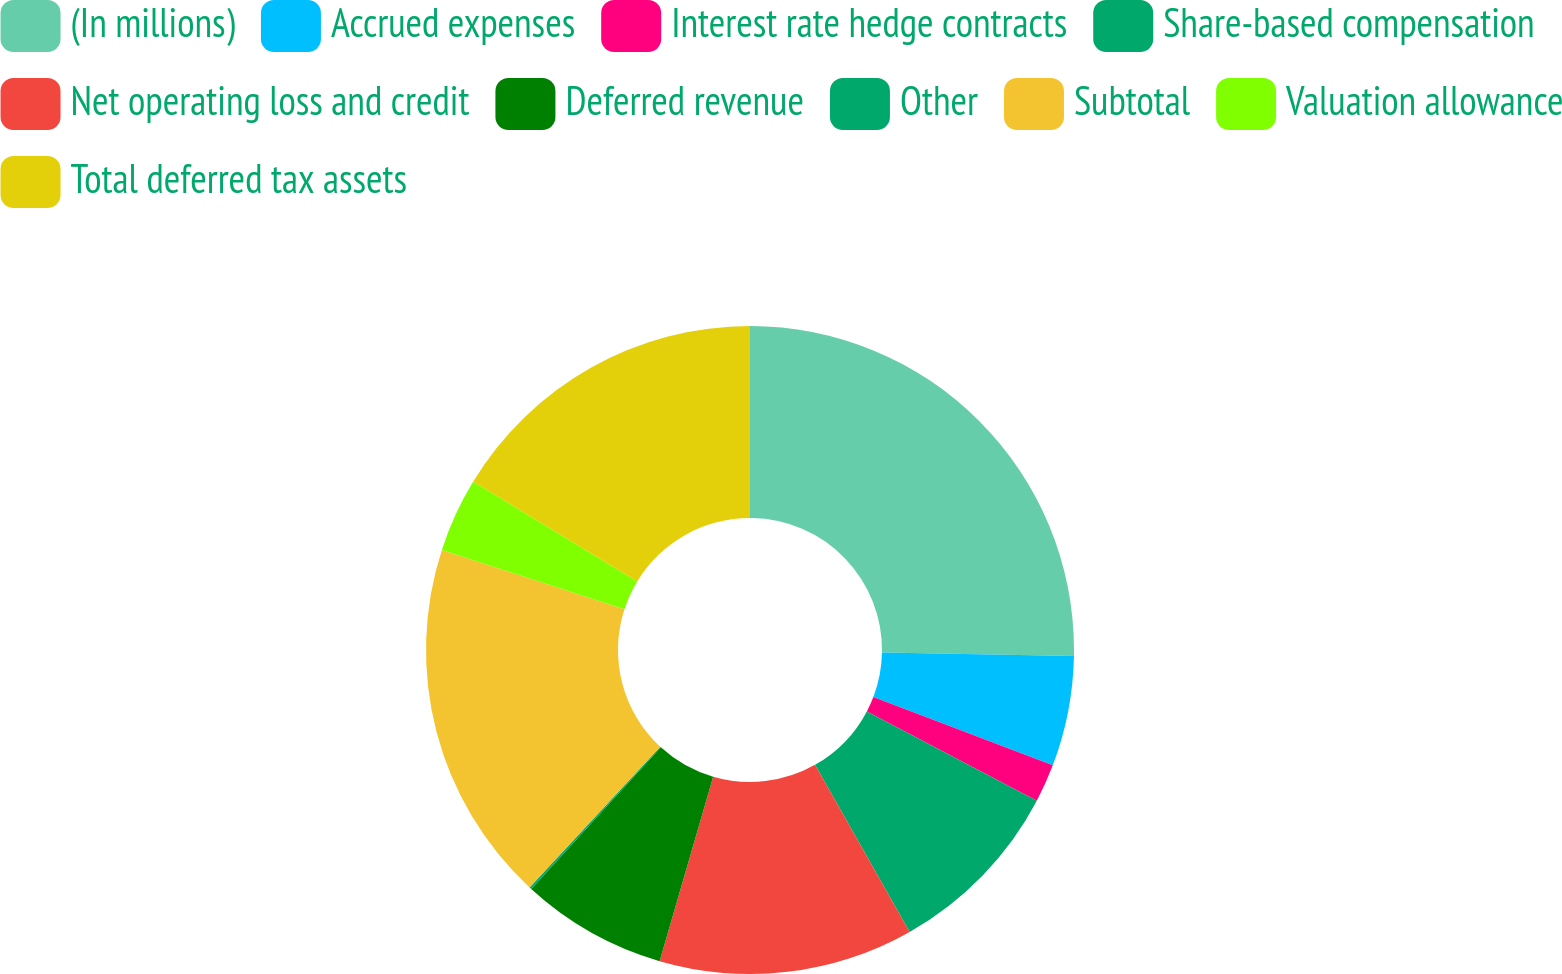Convert chart to OTSL. <chart><loc_0><loc_0><loc_500><loc_500><pie_chart><fcel>(In millions)<fcel>Accrued expenses<fcel>Interest rate hedge contracts<fcel>Share-based compensation<fcel>Net operating loss and credit<fcel>Deferred revenue<fcel>Other<fcel>Subtotal<fcel>Valuation allowance<fcel>Total deferred tax assets<nl><fcel>25.29%<fcel>5.5%<fcel>1.91%<fcel>9.1%<fcel>12.7%<fcel>7.3%<fcel>0.11%<fcel>18.09%<fcel>3.7%<fcel>16.3%<nl></chart> 